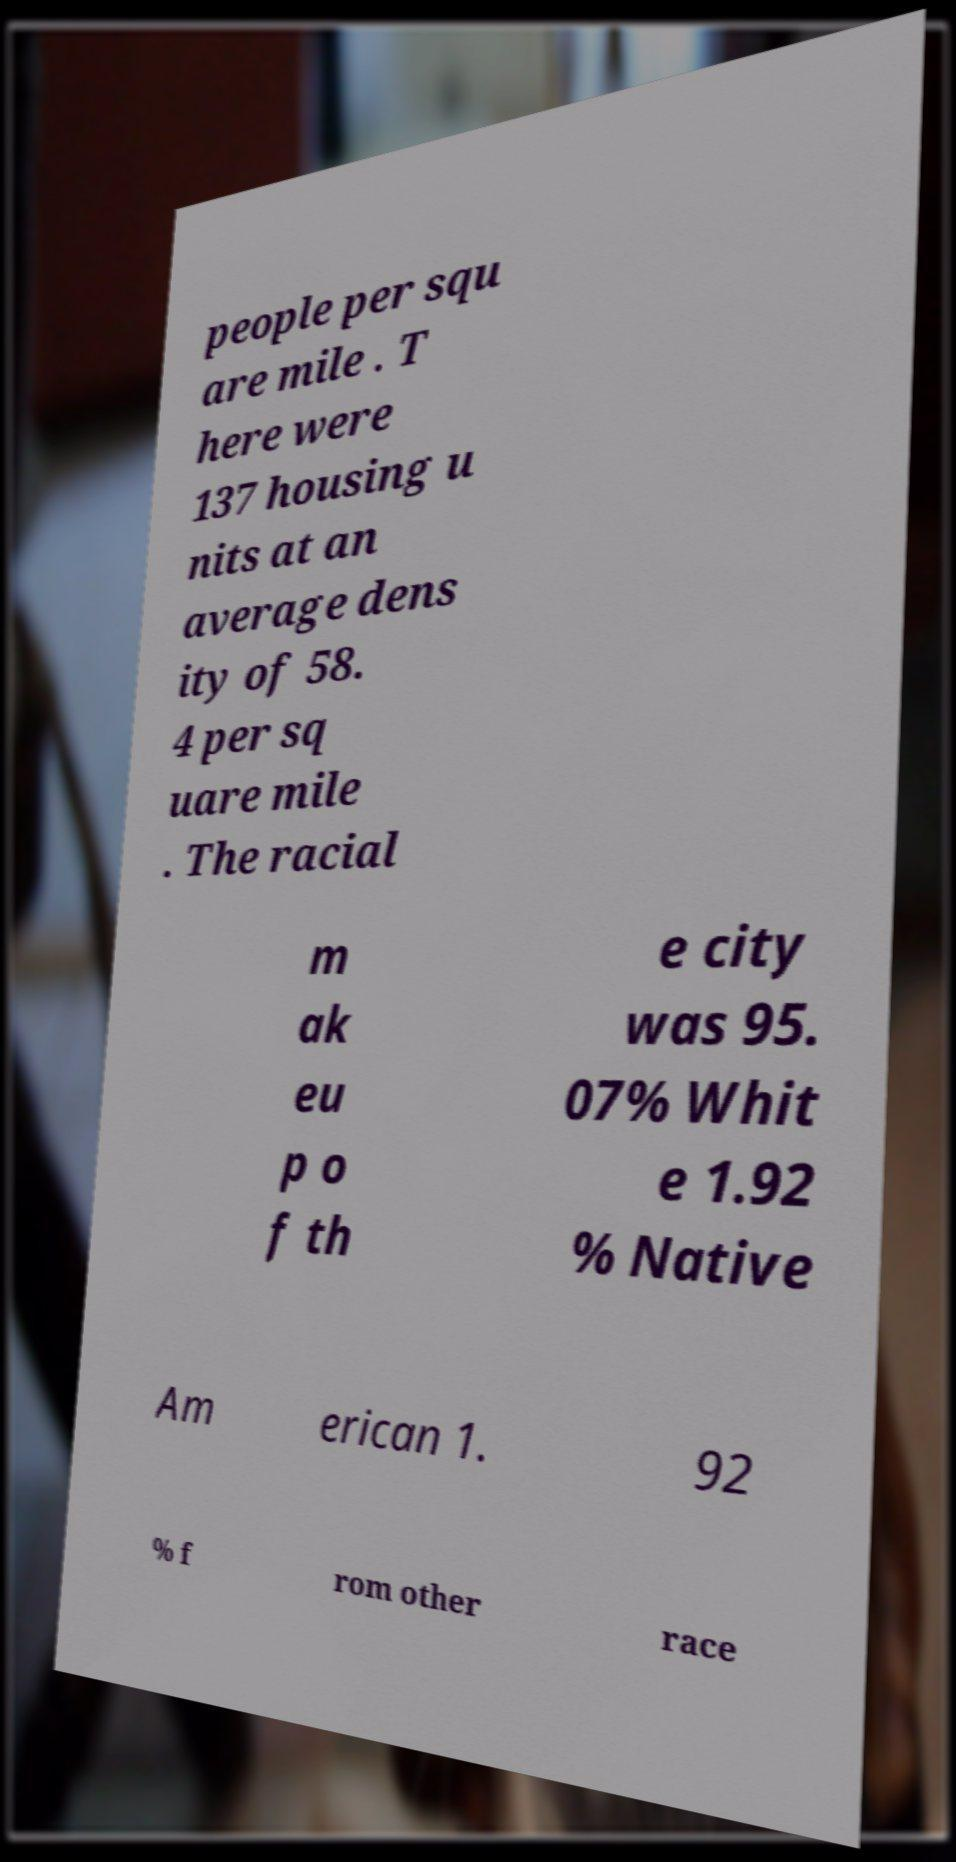I need the written content from this picture converted into text. Can you do that? people per squ are mile . T here were 137 housing u nits at an average dens ity of 58. 4 per sq uare mile . The racial m ak eu p o f th e city was 95. 07% Whit e 1.92 % Native Am erican 1. 92 % f rom other race 